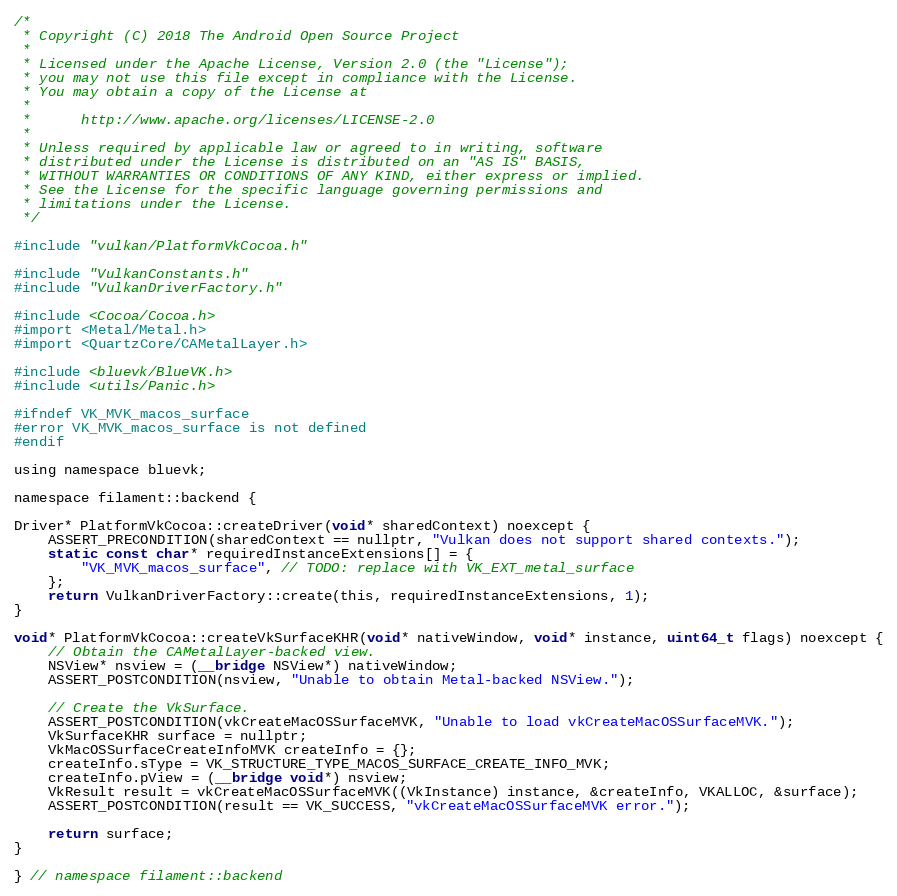<code> <loc_0><loc_0><loc_500><loc_500><_ObjectiveC_>/*
 * Copyright (C) 2018 The Android Open Source Project
 *
 * Licensed under the Apache License, Version 2.0 (the "License");
 * you may not use this file except in compliance with the License.
 * You may obtain a copy of the License at
 *
 *      http://www.apache.org/licenses/LICENSE-2.0
 *
 * Unless required by applicable law or agreed to in writing, software
 * distributed under the License is distributed on an "AS IS" BASIS,
 * WITHOUT WARRANTIES OR CONDITIONS OF ANY KIND, either express or implied.
 * See the License for the specific language governing permissions and
 * limitations under the License.
 */

#include "vulkan/PlatformVkCocoa.h"

#include "VulkanConstants.h"
#include "VulkanDriverFactory.h"

#include <Cocoa/Cocoa.h>
#import <Metal/Metal.h>
#import <QuartzCore/CAMetalLayer.h>

#include <bluevk/BlueVK.h>
#include <utils/Panic.h>

#ifndef VK_MVK_macos_surface
#error VK_MVK_macos_surface is not defined
#endif

using namespace bluevk;

namespace filament::backend {

Driver* PlatformVkCocoa::createDriver(void* sharedContext) noexcept {
    ASSERT_PRECONDITION(sharedContext == nullptr, "Vulkan does not support shared contexts.");
    static const char* requiredInstanceExtensions[] = {
        "VK_MVK_macos_surface", // TODO: replace with VK_EXT_metal_surface
    };
    return VulkanDriverFactory::create(this, requiredInstanceExtensions, 1);
}

void* PlatformVkCocoa::createVkSurfaceKHR(void* nativeWindow, void* instance, uint64_t flags) noexcept {
    // Obtain the CAMetalLayer-backed view.
    NSView* nsview = (__bridge NSView*) nativeWindow;
    ASSERT_POSTCONDITION(nsview, "Unable to obtain Metal-backed NSView.");

    // Create the VkSurface.
    ASSERT_POSTCONDITION(vkCreateMacOSSurfaceMVK, "Unable to load vkCreateMacOSSurfaceMVK.");
    VkSurfaceKHR surface = nullptr;
    VkMacOSSurfaceCreateInfoMVK createInfo = {};
    createInfo.sType = VK_STRUCTURE_TYPE_MACOS_SURFACE_CREATE_INFO_MVK;
    createInfo.pView = (__bridge void*) nsview;
    VkResult result = vkCreateMacOSSurfaceMVK((VkInstance) instance, &createInfo, VKALLOC, &surface);
    ASSERT_POSTCONDITION(result == VK_SUCCESS, "vkCreateMacOSSurfaceMVK error.");

    return surface;
}

} // namespace filament::backend
</code> 